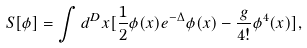Convert formula to latex. <formula><loc_0><loc_0><loc_500><loc_500>S [ \phi ] = \int d ^ { D } x [ \frac { 1 } { 2 } \phi ( x ) e ^ { - \Delta } \phi ( x ) - \frac { g } { 4 ! } \phi ^ { 4 } ( x ) ] ,</formula> 